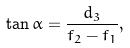<formula> <loc_0><loc_0><loc_500><loc_500>\tan \alpha = \frac { d _ { 3 } } { f _ { 2 } - f _ { 1 } } ,</formula> 